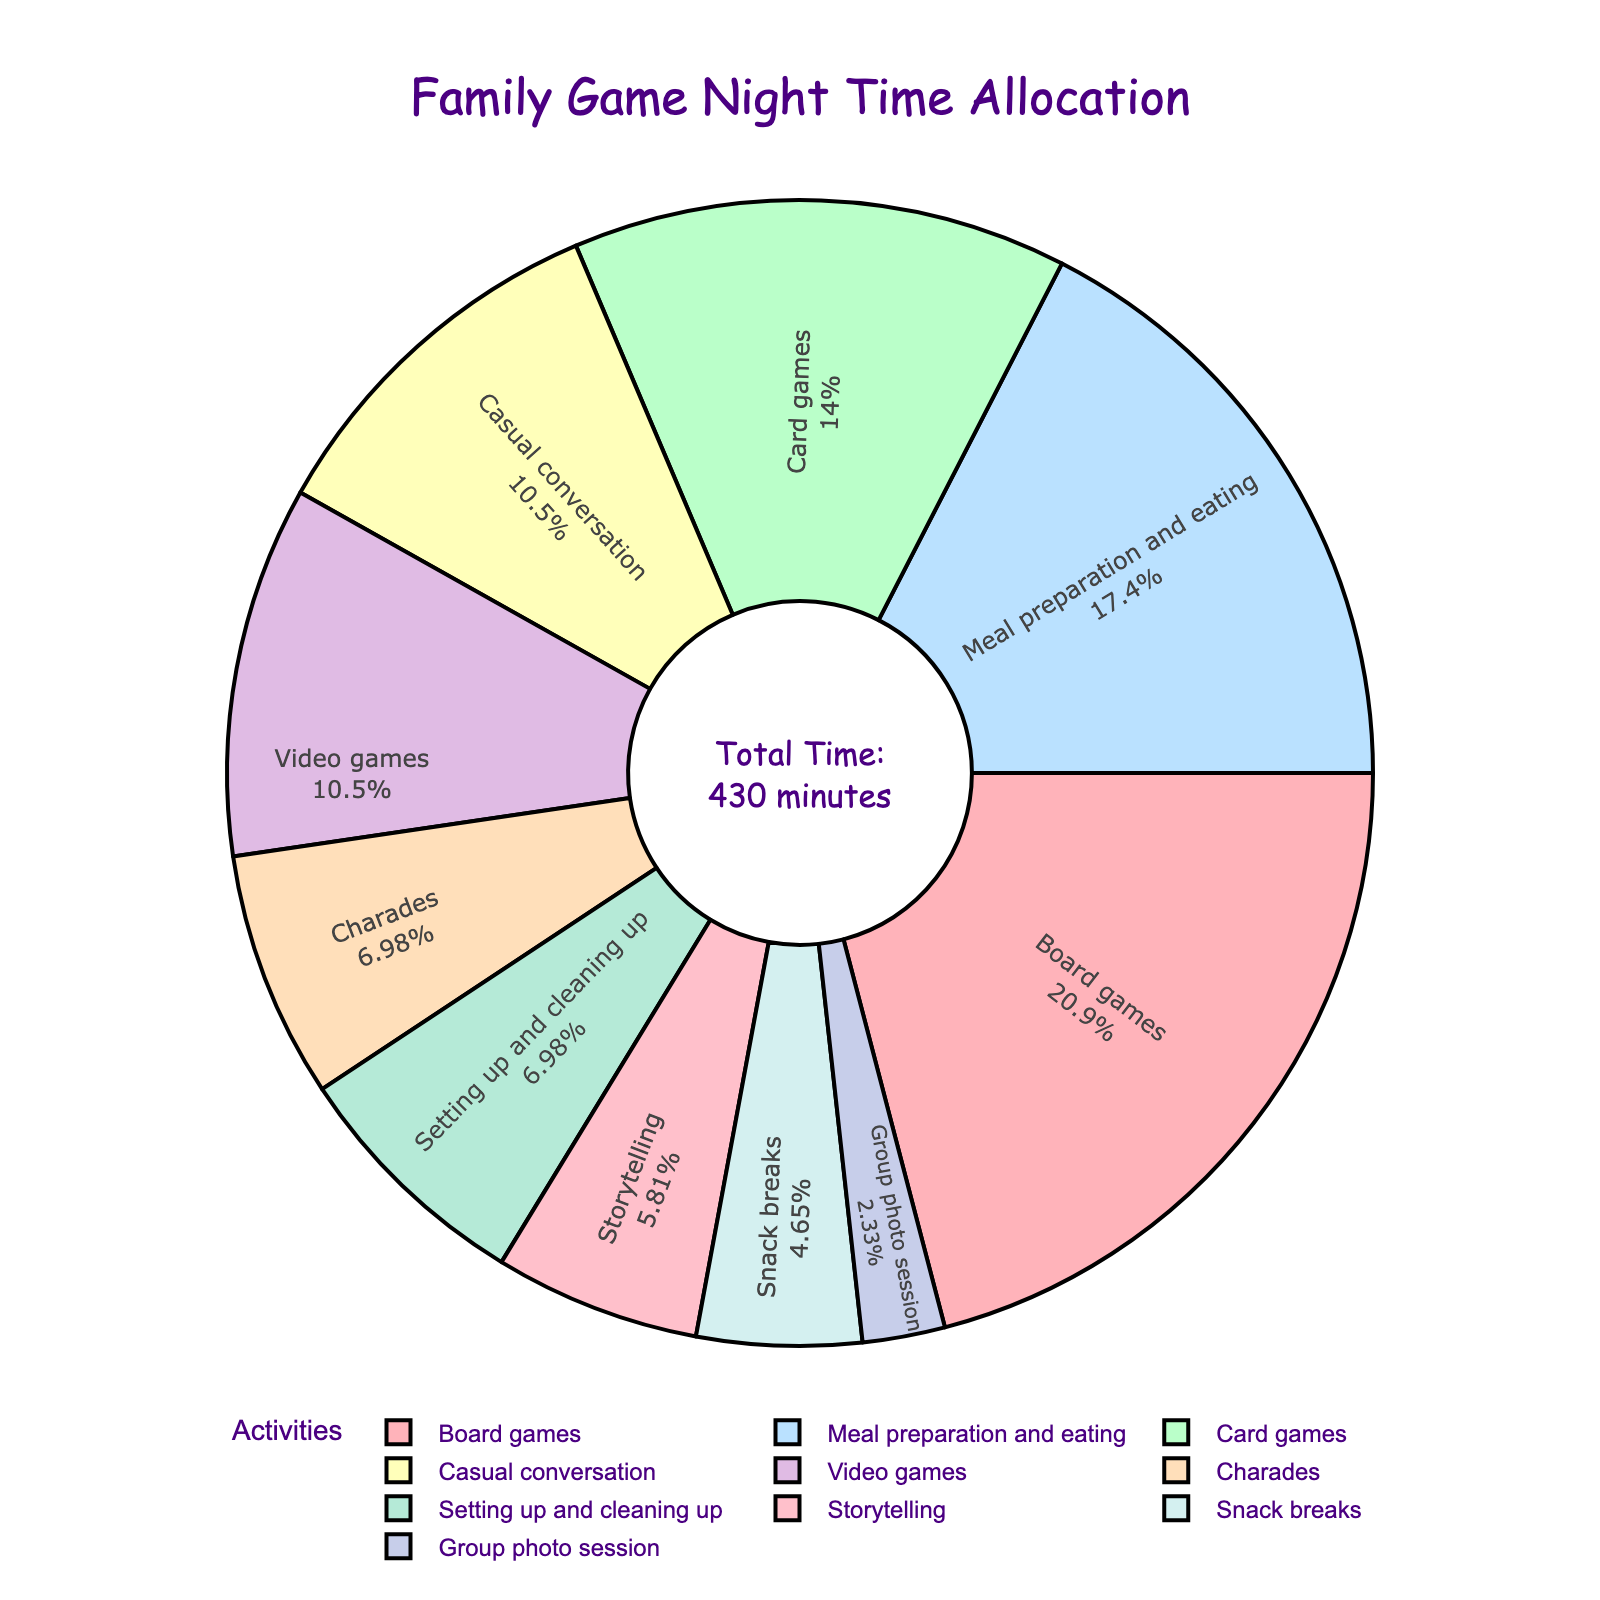What's the activity with the most time allocated? To find the activity with the most time, look for the largest segment in the pie chart. The largest slice represents "Board games," which takes 90 minutes.
Answer: Board games How much total time is spent on games (board, card, and video games combined)? Calculate the time spent on each type of game: board games (90 minutes), card games (60 minutes), and video games (45 minutes). Sum these times: 90 + 60 + 45 = 195 minutes.
Answer: 195 minutes Which two activities have the same allocated time and what is that time? Find segments with the same size. "Casual conversation" and "Video games" both have 45 minutes allocated.
Answer: Casual conversation and Video games, 45 minutes Is more time spent on meal preparation and eating or on storytelling? Compare the segments for "Meal preparation and eating" (75 minutes) and "Storytelling" (25 minutes). "Meal preparation and eating" has more time allocated.
Answer: Meal preparation and eating What percentage of the total time is spent on charades? Find the "Charades" segment and read its percentage. Charades takes up 30 minutes out of the total 430 minutes. The percentage is (30/430)*100 ≈ 6.98%.
Answer: Approximately 6.98% How does the time spent on snack breaks compare with the time spent on casual conversation? Compare the segments for "Snack breaks" (20 minutes) and "Casual conversation" (45 minutes). More time is spent on casual conversation than on snack breaks.
Answer: Snack breaks less than casual conversation What is the total time spent on non-game activities? Non-game activities include meal preparation and eating (75 minutes), casual conversation (45 minutes), charades (30 minutes), snack breaks (20 minutes), storytelling (25 minutes), setting up and cleaning up (30 minutes), and group photo session (10 minutes). Sum these times: 75 + 45 + 30 + 20 + 25 + 30 + 10 = 235 minutes.
Answer: 235 minutes Which activity has the least time allocated? Look for the smallest segment in the pie chart. The smallest slice represents the "Group photo session," which takes 10 minutes.
Answer: Group photo session What is the average time allocated per activity? Calculate the total time spent on all activities (430 minutes) and divide by the number of activities (10). The average time is 430/10 = 43 minutes.
Answer: 43 minutes 